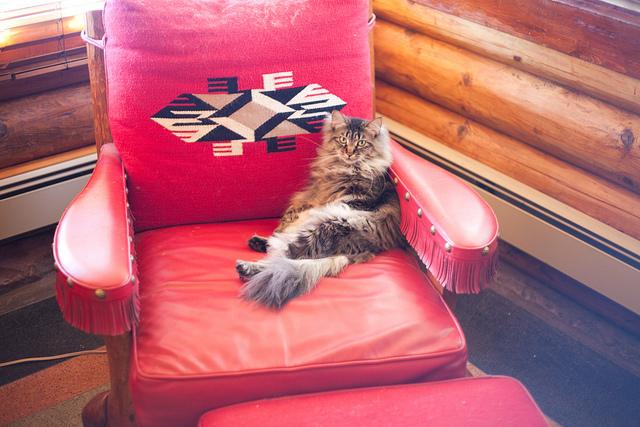What are the walls made of?
Quick response, please. Wood. What animal is in the picture?
Give a very brief answer. Cat. What color is the couch?
Concise answer only. Red. 